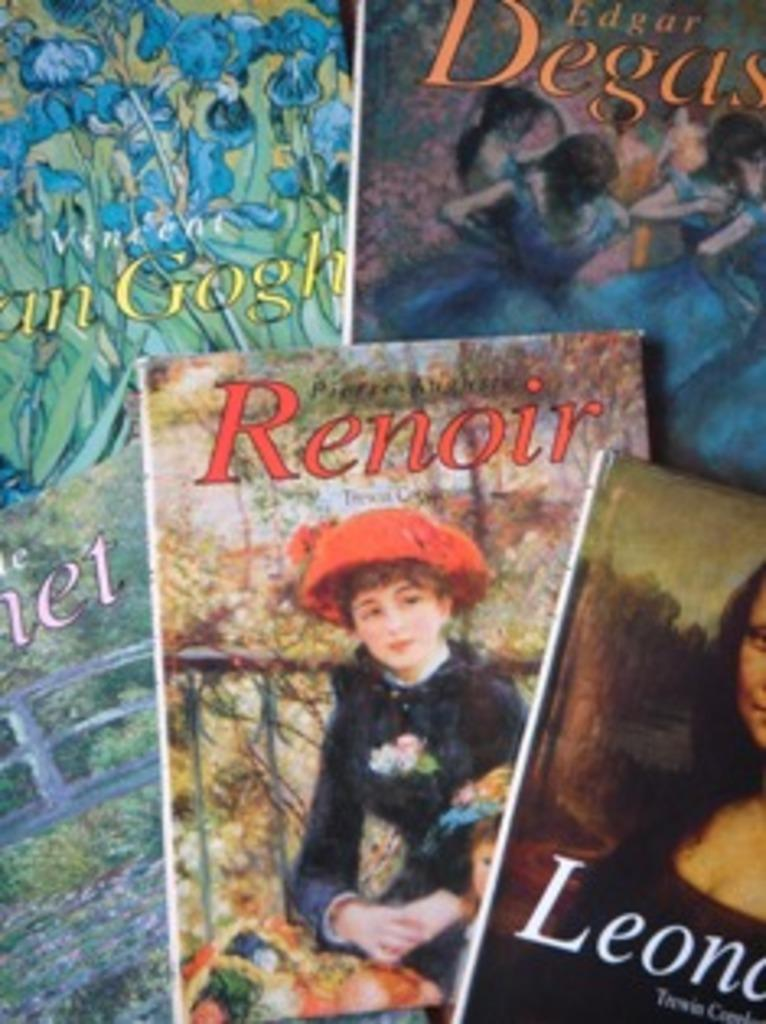<image>
Provide a brief description of the given image. A few magazines placed together one named Renoir. 